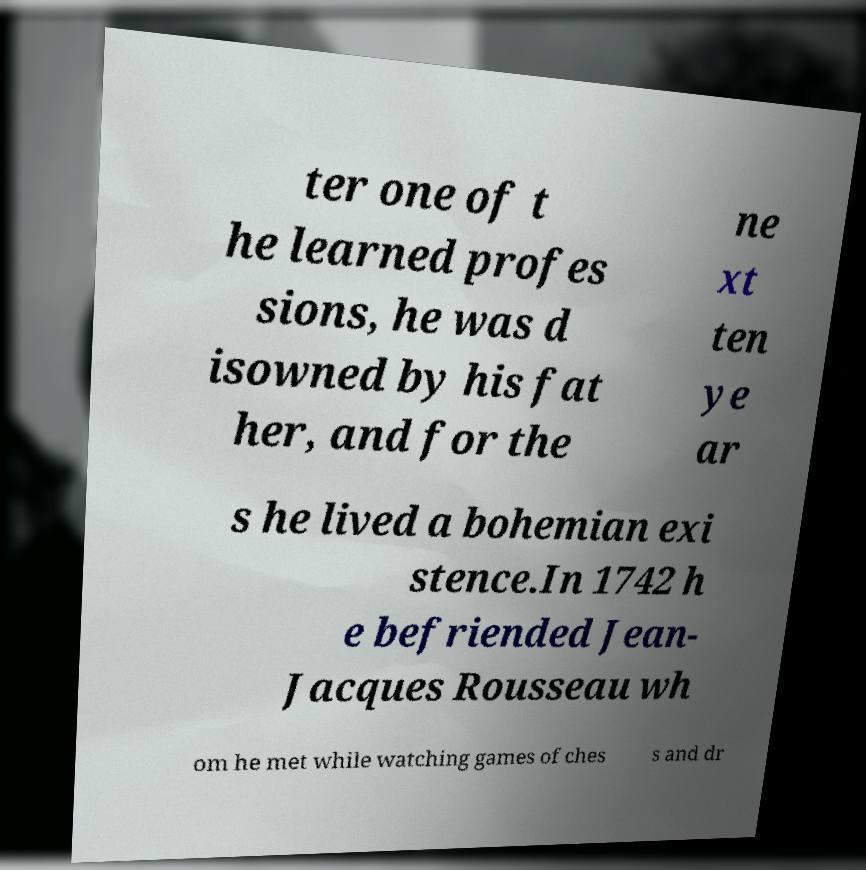I need the written content from this picture converted into text. Can you do that? ter one of t he learned profes sions, he was d isowned by his fat her, and for the ne xt ten ye ar s he lived a bohemian exi stence.In 1742 h e befriended Jean- Jacques Rousseau wh om he met while watching games of ches s and dr 